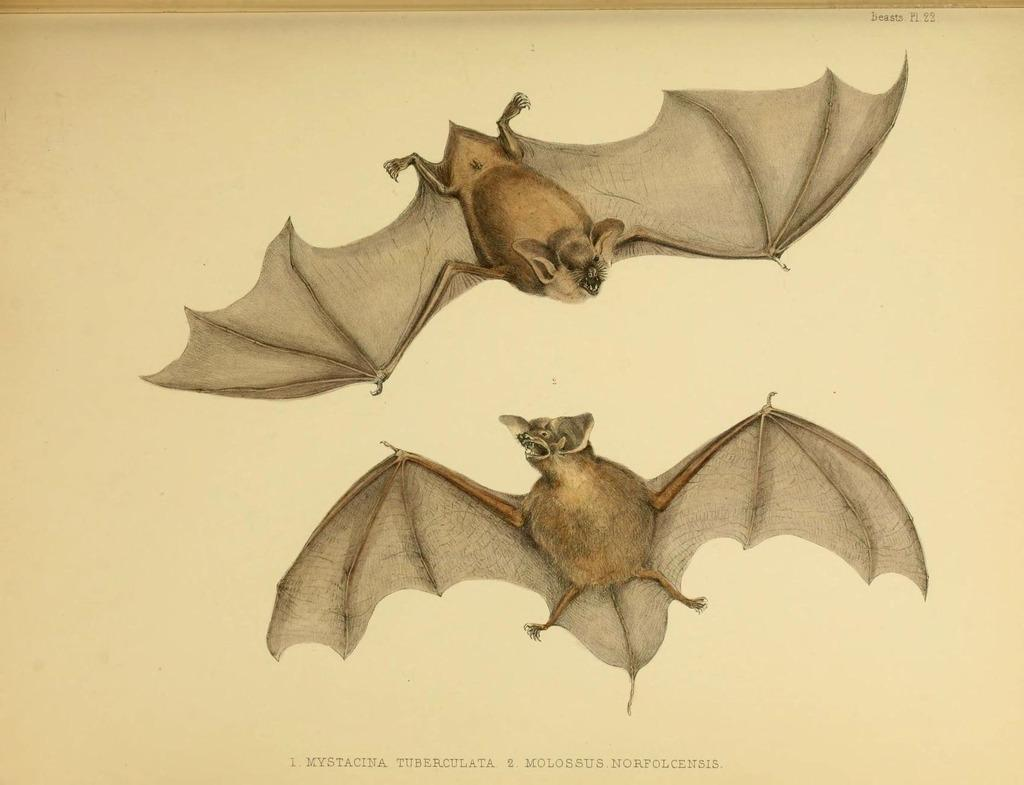What type of animals are in the image? There are bats in the image. Is there any text present in the image? Yes, there is text at the bottom of the image. What type of lead can be seen in the image? There is no lead present in the image. How many feet are visible in the image? There are no feet visible in the image. 